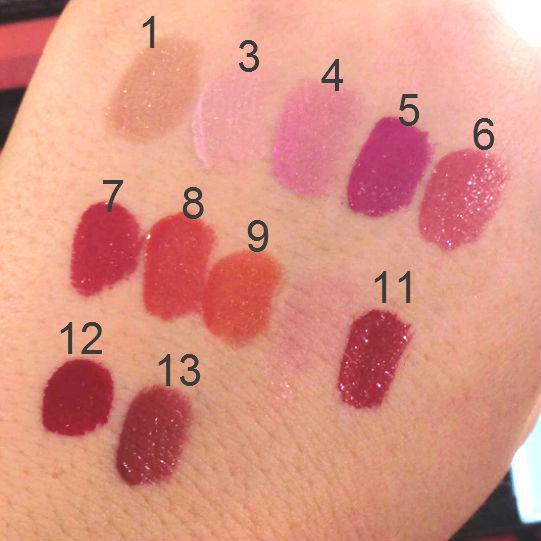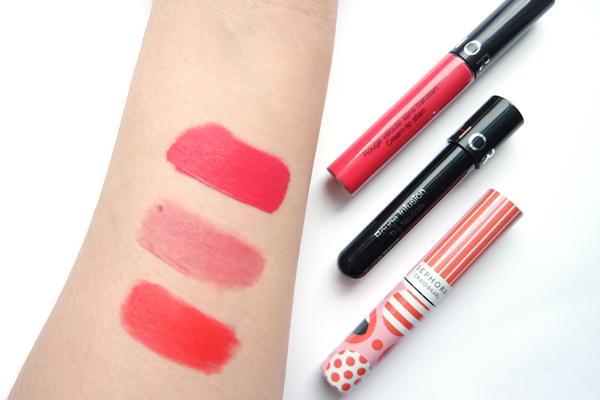The first image is the image on the left, the second image is the image on the right. Given the left and right images, does the statement "Right image shows one pair of tinted lips." hold true? Answer yes or no. No. The first image is the image on the left, the second image is the image on the right. For the images displayed, is the sentence "A pair of lips is visible in the right image" factually correct? Answer yes or no. No. 